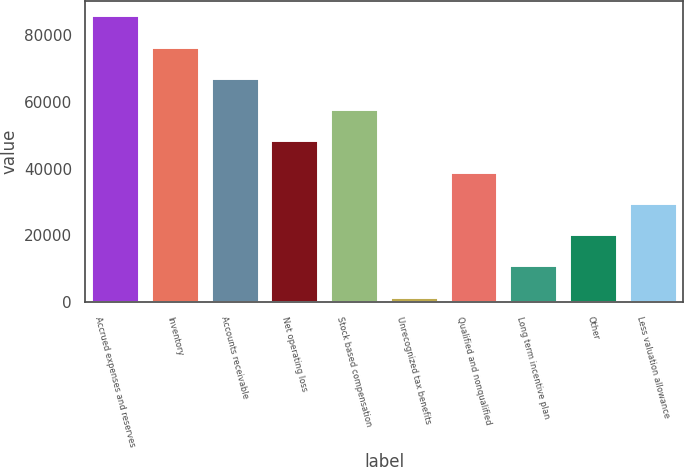Convert chart to OTSL. <chart><loc_0><loc_0><loc_500><loc_500><bar_chart><fcel>Accrued expenses and reserves<fcel>Inventory<fcel>Accounts receivable<fcel>Net operating loss<fcel>Stock based compensation<fcel>Unrecognized tax benefits<fcel>Qualified and nonqualified<fcel>Long term incentive plan<fcel>Other<fcel>Less valuation allowance<nl><fcel>85969<fcel>76601<fcel>67233<fcel>48497<fcel>57865<fcel>1657<fcel>39129<fcel>11025<fcel>20393<fcel>29761<nl></chart> 